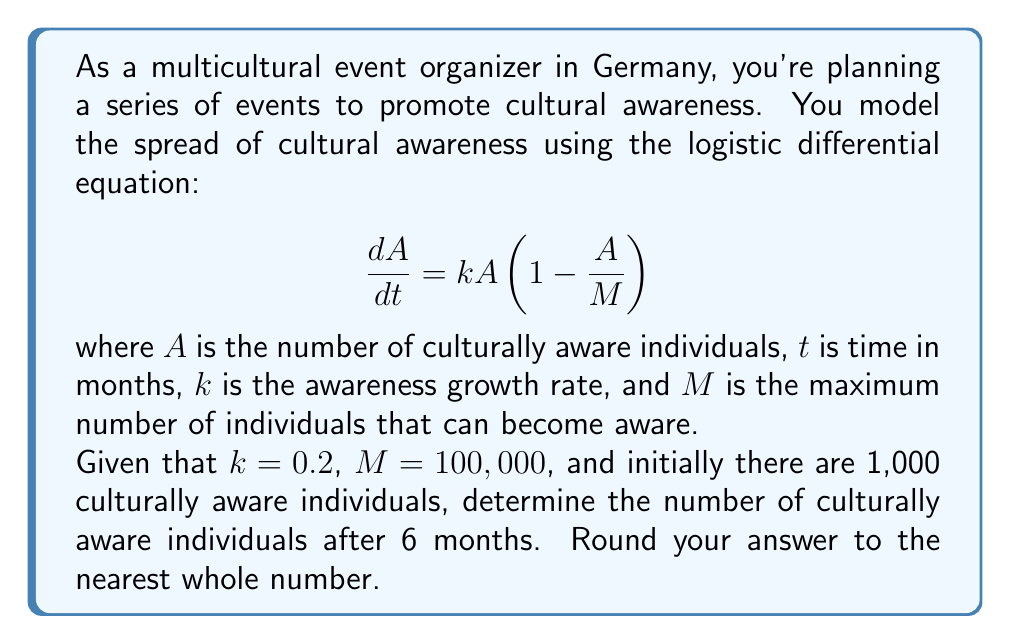Give your solution to this math problem. To solve this problem, we need to use the solution to the logistic differential equation:

$$A(t) = \frac{M}{1 + (\frac{M}{A_0} - 1)e^{-kt}}$$

Where $A_0$ is the initial number of culturally aware individuals.

Given:
$k = 0.2$
$M = 100,000$
$A_0 = 1,000$
$t = 6$ months

Let's substitute these values into the equation:

$$A(6) = \frac{100,000}{1 + (\frac{100,000}{1,000} - 1)e^{-0.2 \cdot 6}}$$

$$= \frac{100,000}{1 + (100 - 1)e^{-1.2}}$$

$$= \frac{100,000}{1 + 99e^{-1.2}}$$

Now, let's calculate this step by step:

1. Calculate $e^{-1.2}$:
   $e^{-1.2} \approx 0.301194$

2. Multiply by 99:
   $99 \cdot 0.301194 \approx 29.818206$

3. Add 1:
   $1 + 29.818206 \approx 30.818206$

4. Divide 100,000 by this result:
   $\frac{100,000}{30.818206} \approx 3,244.8$

5. Round to the nearest whole number:
   3,245

Therefore, after 6 months, there will be approximately 3,245 culturally aware individuals.
Answer: 3,245 individuals 